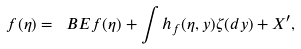Convert formula to latex. <formula><loc_0><loc_0><loc_500><loc_500>f ( \eta ) = \ B E f ( \eta ) + \int h _ { f } ( \eta , y ) \zeta ( d y ) + X ^ { \prime } ,</formula> 